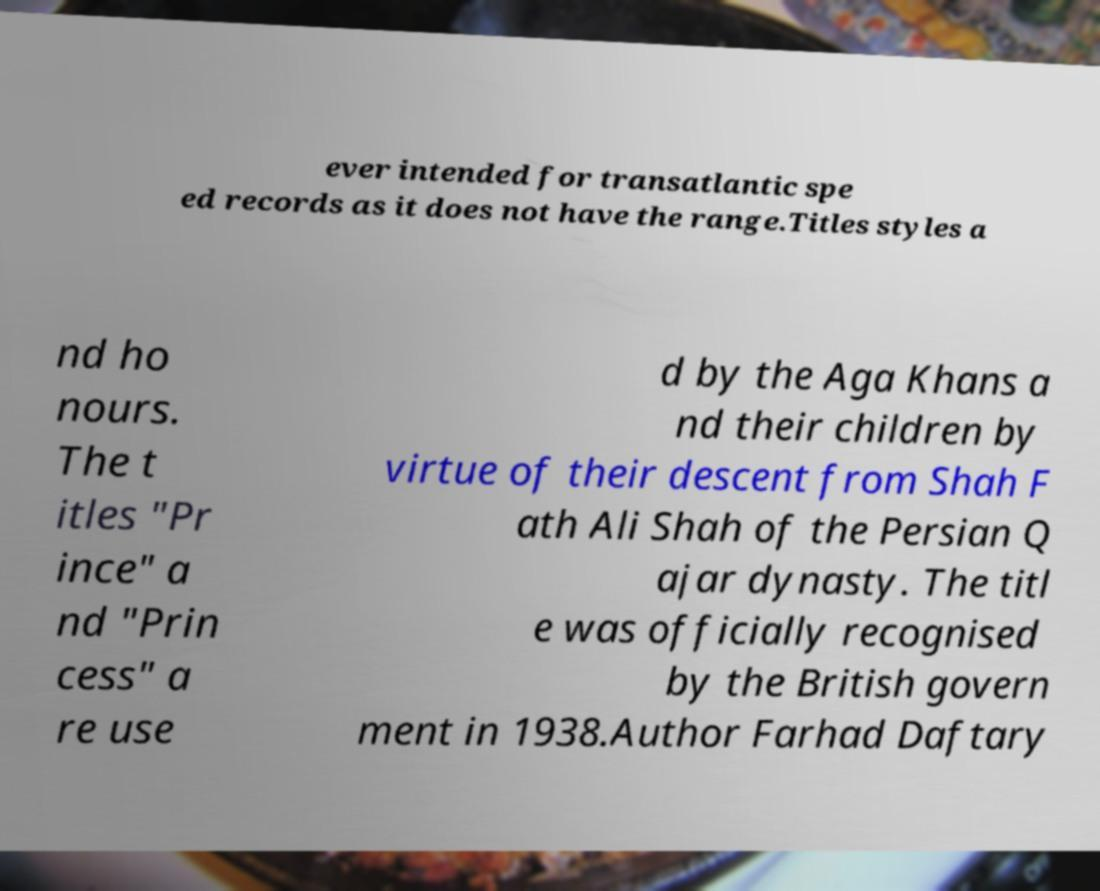Please identify and transcribe the text found in this image. ever intended for transatlantic spe ed records as it does not have the range.Titles styles a nd ho nours. The t itles "Pr ince" a nd "Prin cess" a re use d by the Aga Khans a nd their children by virtue of their descent from Shah F ath Ali Shah of the Persian Q ajar dynasty. The titl e was officially recognised by the British govern ment in 1938.Author Farhad Daftary 